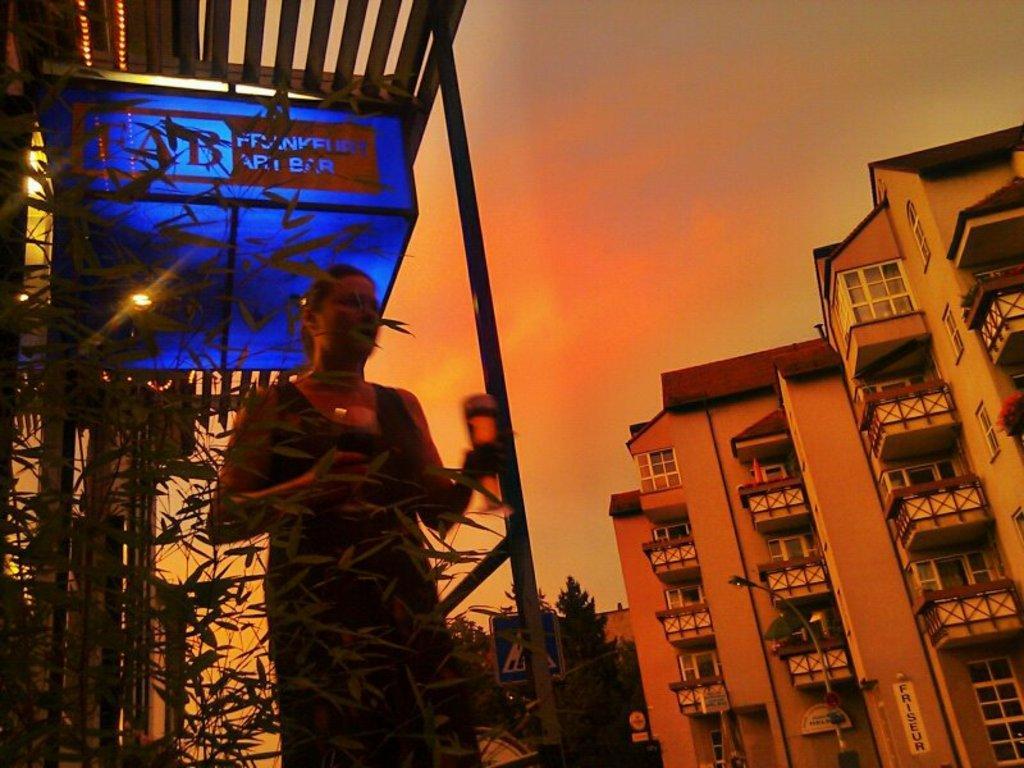In one or two sentences, can you explain what this image depicts? In this picture I can see there is a woman standing here and there are some buildings on the right and there are some street lights and the sky is clear. 